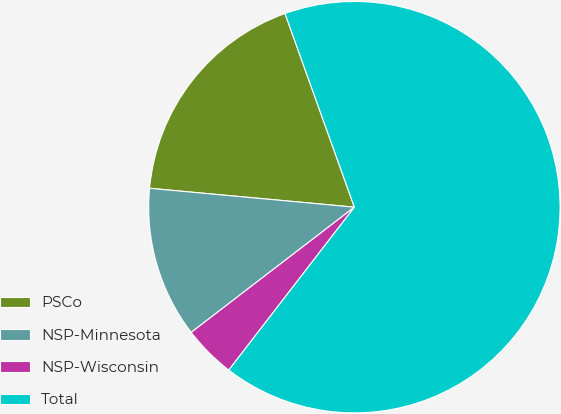Convert chart. <chart><loc_0><loc_0><loc_500><loc_500><pie_chart><fcel>PSCo<fcel>NSP-Minnesota<fcel>NSP-Wisconsin<fcel>Total<nl><fcel>18.06%<fcel>11.88%<fcel>4.13%<fcel>65.93%<nl></chart> 